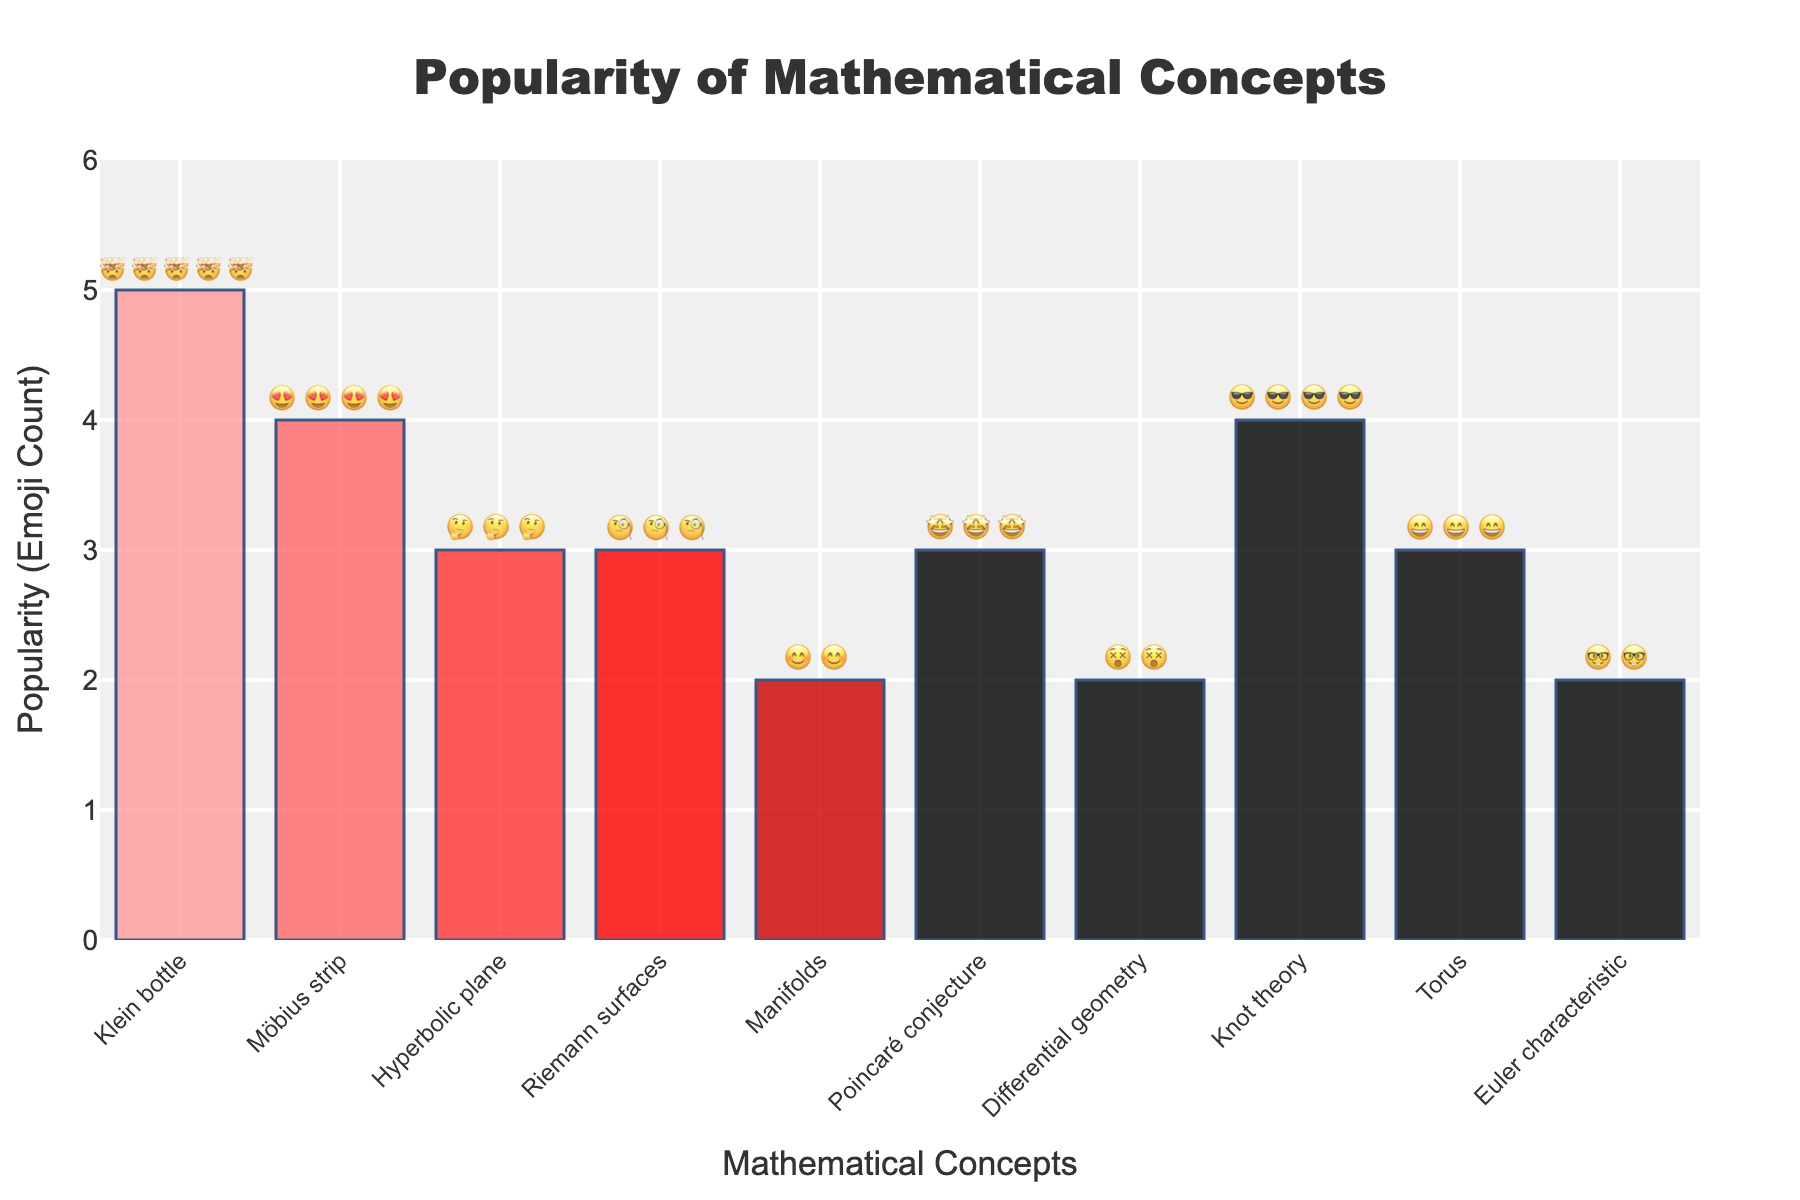What's the most popular mathematical concept? The figure shows the 'Klein bottle' with 5 emojis, the highest count among all concepts
Answer: Klein bottle How many emojis are used to represent the popularity of 'Torus'? The 'Torus' concept has 3 '😄' emojis next to it in the plot
Answer: 3 Which concept is less popular: 'Manifolds' or 'Differential geometry'? 'Manifolds' have 2 '😊' emojis, while 'Differential geometry' has 2 '😵' emojis; both are equally popular
Answer: Equally popular What is the average popularity (in emoji count) of the concepts shown? Sum the emoji counts: 5 (Klein bottle) + 4 (Möbius strip) + 3 (Hyperbolic plane) + 3 (Riemann surfaces) + 2 (Manifolds) + 3 (Poincaré conjecture) + 2 (Differential geometry) + 4 (Knot theory) + 3 (Torus) + 2 (Euler characteristic) = 31. There are 10 concepts, so 31/10 = 3.1
Answer: 3.1 Which concepts have exactly 3 emojis for popularity? The concepts with exactly 3 emojis are 'Hyperbolic plane', 'Riemann surfaces', 'Poincaré conjecture', and 'Torus'
Answer: Hyperbolic plane, Riemann surfaces, Poincaré conjecture, Torus Are there more concepts with a popularity of 2 emojis or 4 emojis? By counting, there are 3 concepts with 2 emojis: 'Manifolds', 'Differential geometry', 'Euler characteristic'; there are 2 concepts with 4 emojis: 'Möbius strip', 'Knot theory'
Answer: More with 2 emojis What is the total number of emojis displayed in the bar chart? Sum the emoji counts from each concept: 5 + 4 + 3 + 3 + 2 + 3 + 2 + 4 + 3 + 2 = 31
Answer: 31 Which concept received the least enthusiastic reaction, and what was it? 'Euler characteristic' has 2 '🤓' emojis, indicating a more contemplative reaction
Answer: Euler characteristic with '🤓' emojis 